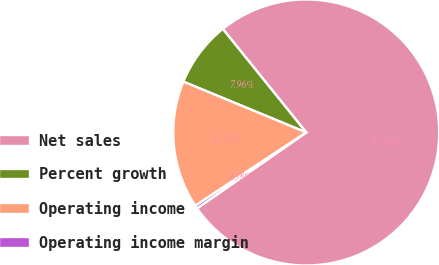Convert chart. <chart><loc_0><loc_0><loc_500><loc_500><pie_chart><fcel>Net sales<fcel>Percent growth<fcel>Operating income<fcel>Operating income margin<nl><fcel>76.13%<fcel>7.96%<fcel>15.53%<fcel>0.38%<nl></chart> 